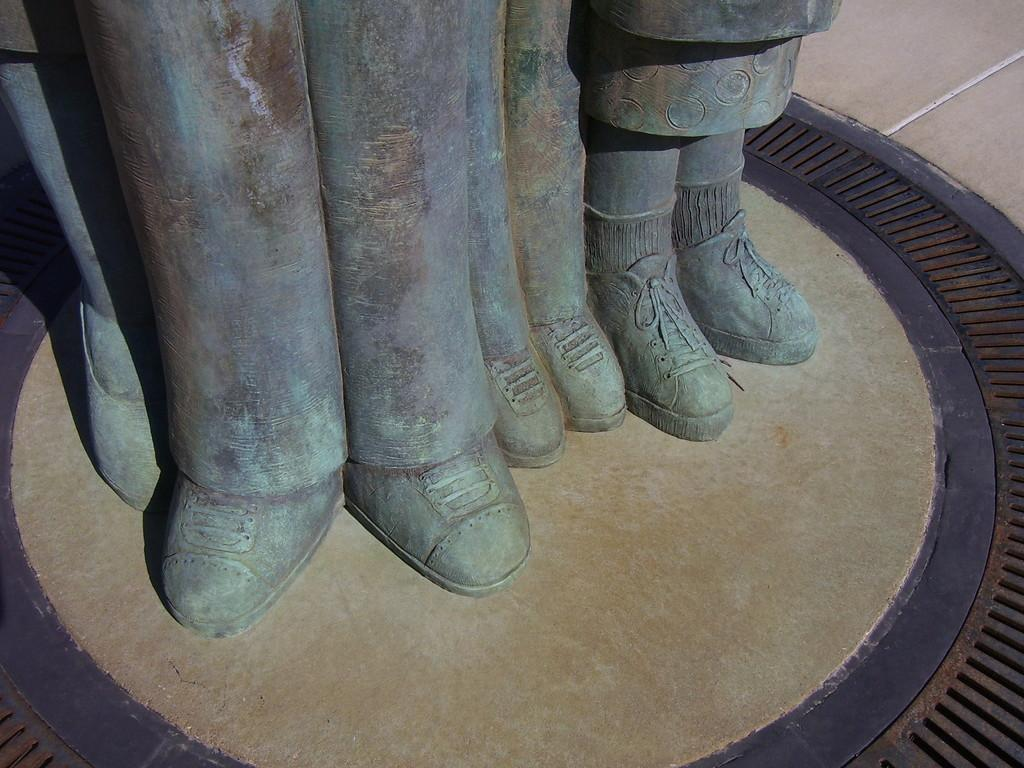What can be seen in the image? There are statues in the image. What else can be seen in the background of the image? There is a road visible in the background of the image. What is the interest rate on the statues in the image? There is no mention of interest rates in the image, as it features statues and a road. 